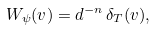Convert formula to latex. <formula><loc_0><loc_0><loc_500><loc_500>W _ { \psi } ( v ) = d ^ { - n } \, \delta _ { T } ( v ) ,</formula> 